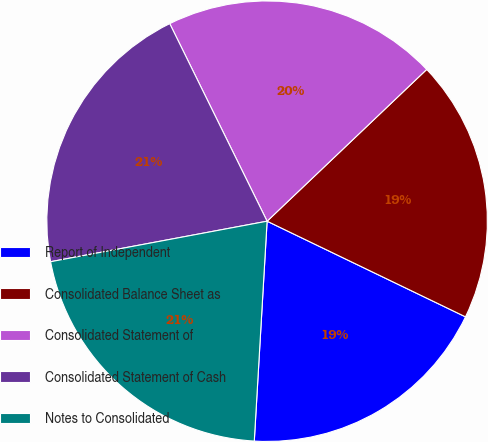Convert chart. <chart><loc_0><loc_0><loc_500><loc_500><pie_chart><fcel>Report of Independent<fcel>Consolidated Balance Sheet as<fcel>Consolidated Statement of<fcel>Consolidated Statement of Cash<fcel>Notes to Consolidated<nl><fcel>18.78%<fcel>19.25%<fcel>20.19%<fcel>20.66%<fcel>21.13%<nl></chart> 